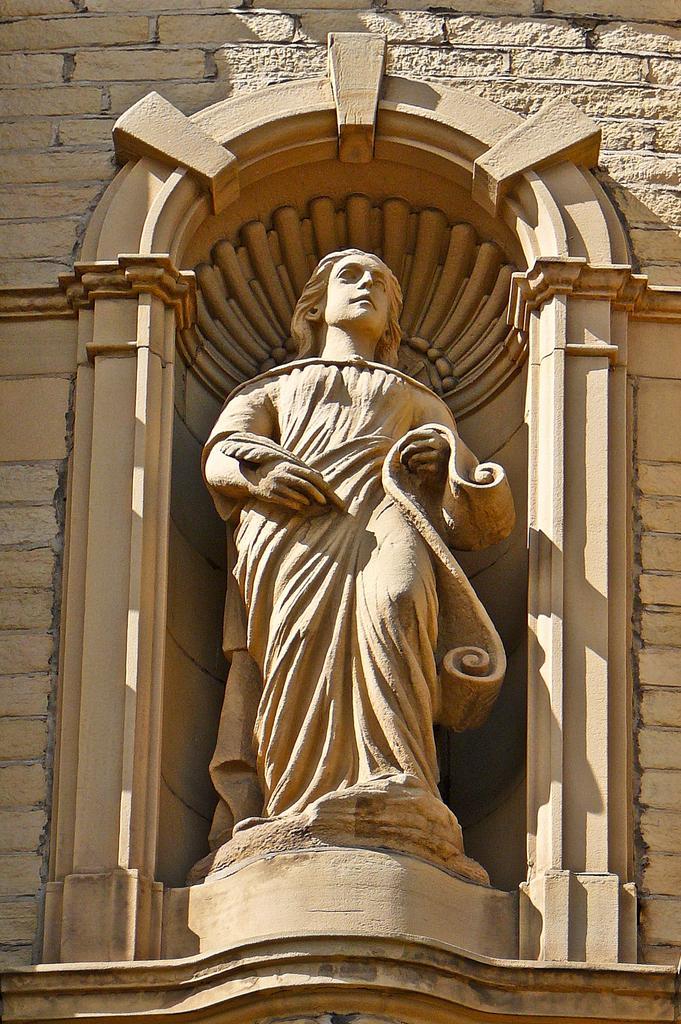In one or two sentences, can you explain what this image depicts? In this image there is a depiction of a person as we can see in middle of this image and there is a wall in the background. 